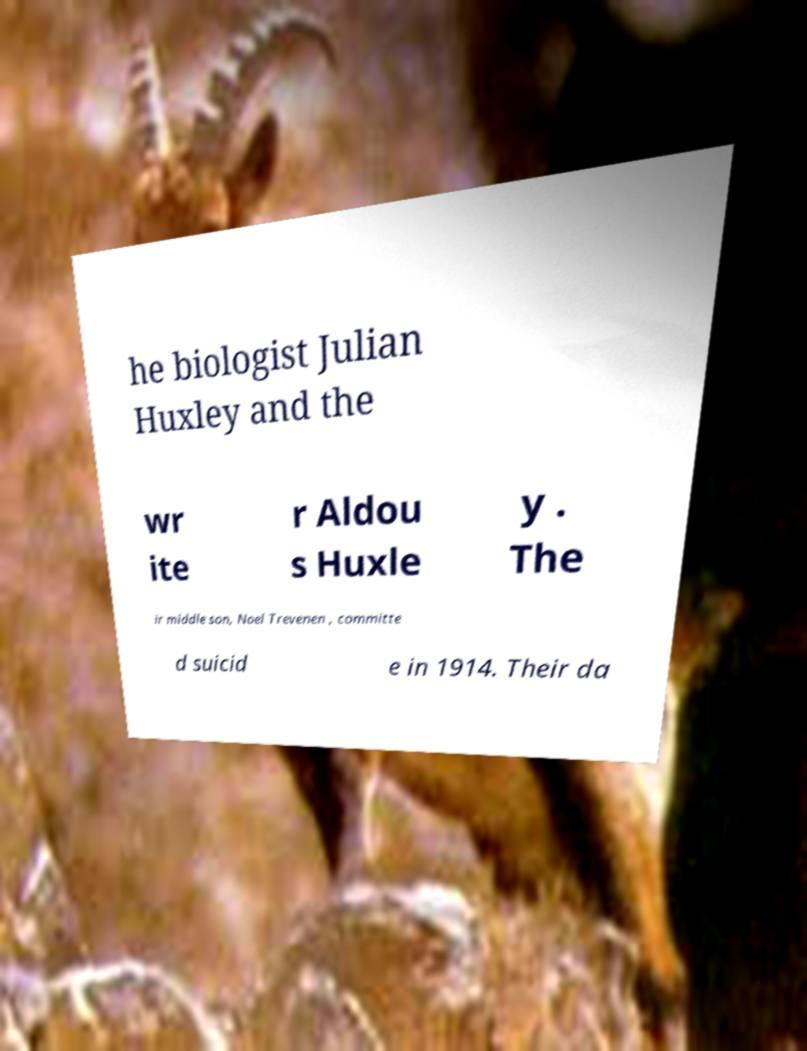Could you assist in decoding the text presented in this image and type it out clearly? he biologist Julian Huxley and the wr ite r Aldou s Huxle y . The ir middle son, Noel Trevenen , committe d suicid e in 1914. Their da 